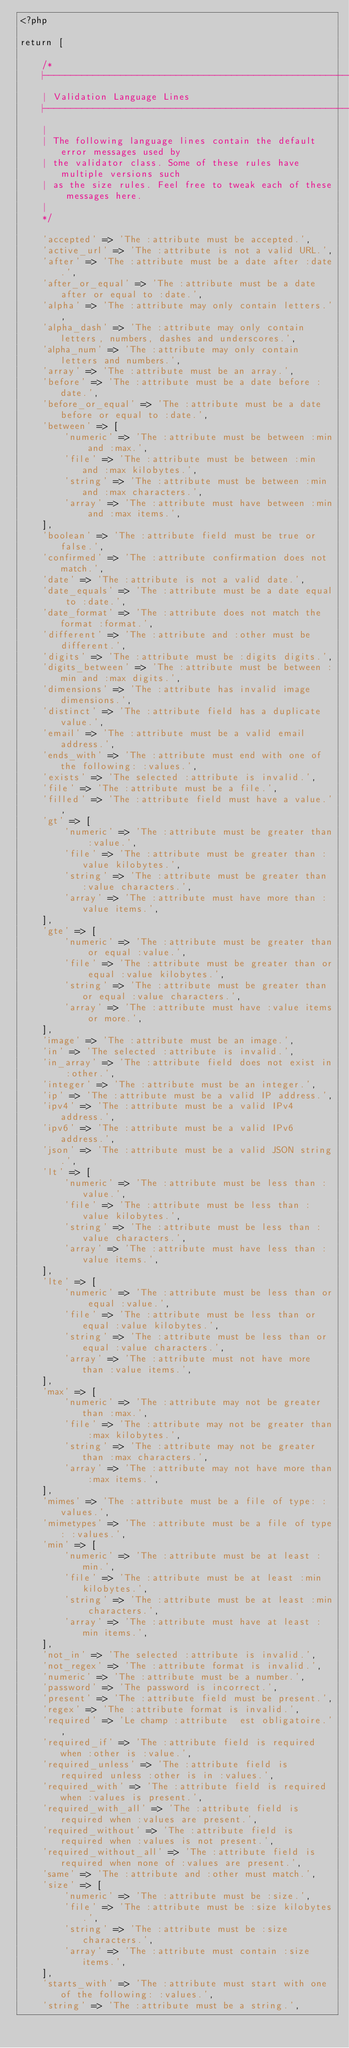Convert code to text. <code><loc_0><loc_0><loc_500><loc_500><_PHP_><?php

return [

    /*
    |--------------------------------------------------------------------------
    | Validation Language Lines
    |--------------------------------------------------------------------------
    |
    | The following language lines contain the default error messages used by
    | the validator class. Some of these rules have multiple versions such
    | as the size rules. Feel free to tweak each of these messages here.
    |
    */

    'accepted' => 'The :attribute must be accepted.',
    'active_url' => 'The :attribute is not a valid URL.',
    'after' => 'The :attribute must be a date after :date.',
    'after_or_equal' => 'The :attribute must be a date after or equal to :date.',
    'alpha' => 'The :attribute may only contain letters.',
    'alpha_dash' => 'The :attribute may only contain letters, numbers, dashes and underscores.',
    'alpha_num' => 'The :attribute may only contain letters and numbers.',
    'array' => 'The :attribute must be an array.',
    'before' => 'The :attribute must be a date before :date.',
    'before_or_equal' => 'The :attribute must be a date before or equal to :date.',
    'between' => [
        'numeric' => 'The :attribute must be between :min and :max.',
        'file' => 'The :attribute must be between :min and :max kilobytes.',
        'string' => 'The :attribute must be between :min and :max characters.',
        'array' => 'The :attribute must have between :min and :max items.',
    ],
    'boolean' => 'The :attribute field must be true or false.',
    'confirmed' => 'The :attribute confirmation does not match.',
    'date' => 'The :attribute is not a valid date.',
    'date_equals' => 'The :attribute must be a date equal to :date.',
    'date_format' => 'The :attribute does not match the format :format.',
    'different' => 'The :attribute and :other must be different.',
    'digits' => 'The :attribute must be :digits digits.',
    'digits_between' => 'The :attribute must be between :min and :max digits.',
    'dimensions' => 'The :attribute has invalid image dimensions.',
    'distinct' => 'The :attribute field has a duplicate value.',
    'email' => 'The :attribute must be a valid email address.',
    'ends_with' => 'The :attribute must end with one of the following: :values.',
    'exists' => 'The selected :attribute is invalid.',
    'file' => 'The :attribute must be a file.',
    'filled' => 'The :attribute field must have a value.',
    'gt' => [
        'numeric' => 'The :attribute must be greater than :value.',
        'file' => 'The :attribute must be greater than :value kilobytes.',
        'string' => 'The :attribute must be greater than :value characters.',
        'array' => 'The :attribute must have more than :value items.',
    ],
    'gte' => [
        'numeric' => 'The :attribute must be greater than or equal :value.',
        'file' => 'The :attribute must be greater than or equal :value kilobytes.',
        'string' => 'The :attribute must be greater than or equal :value characters.',
        'array' => 'The :attribute must have :value items or more.',
    ],
    'image' => 'The :attribute must be an image.',
    'in' => 'The selected :attribute is invalid.',
    'in_array' => 'The :attribute field does not exist in :other.',
    'integer' => 'The :attribute must be an integer.',
    'ip' => 'The :attribute must be a valid IP address.',
    'ipv4' => 'The :attribute must be a valid IPv4 address.',
    'ipv6' => 'The :attribute must be a valid IPv6 address.',
    'json' => 'The :attribute must be a valid JSON string.',
    'lt' => [
        'numeric' => 'The :attribute must be less than :value.',
        'file' => 'The :attribute must be less than :value kilobytes.',
        'string' => 'The :attribute must be less than :value characters.',
        'array' => 'The :attribute must have less than :value items.',
    ],
    'lte' => [
        'numeric' => 'The :attribute must be less than or equal :value.',
        'file' => 'The :attribute must be less than or equal :value kilobytes.',
        'string' => 'The :attribute must be less than or equal :value characters.',
        'array' => 'The :attribute must not have more than :value items.',
    ],
    'max' => [
        'numeric' => 'The :attribute may not be greater than :max.',
        'file' => 'The :attribute may not be greater than :max kilobytes.',
        'string' => 'The :attribute may not be greater than :max characters.',
        'array' => 'The :attribute may not have more than :max items.',
    ],
    'mimes' => 'The :attribute must be a file of type: :values.',
    'mimetypes' => 'The :attribute must be a file of type: :values.',
    'min' => [
        'numeric' => 'The :attribute must be at least :min.',
        'file' => 'The :attribute must be at least :min kilobytes.',
        'string' => 'The :attribute must be at least :min characters.',
        'array' => 'The :attribute must have at least :min items.',
    ],
    'not_in' => 'The selected :attribute is invalid.',
    'not_regex' => 'The :attribute format is invalid.',
    'numeric' => 'The :attribute must be a number.',
    'password' => 'The password is incorrect.',
    'present' => 'The :attribute field must be present.',
    'regex' => 'The :attribute format is invalid.',
    'required' => 'Le champ :attribute  est obligatoire.',
    'required_if' => 'The :attribute field is required when :other is :value.',
    'required_unless' => 'The :attribute field is required unless :other is in :values.',
    'required_with' => 'The :attribute field is required when :values is present.',
    'required_with_all' => 'The :attribute field is required when :values are present.',
    'required_without' => 'The :attribute field is required when :values is not present.',
    'required_without_all' => 'The :attribute field is required when none of :values are present.',
    'same' => 'The :attribute and :other must match.',
    'size' => [
        'numeric' => 'The :attribute must be :size.',
        'file' => 'The :attribute must be :size kilobytes.',
        'string' => 'The :attribute must be :size characters.',
        'array' => 'The :attribute must contain :size items.',
    ],
    'starts_with' => 'The :attribute must start with one of the following: :values.',
    'string' => 'The :attribute must be a string.',</code> 